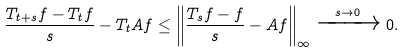Convert formula to latex. <formula><loc_0><loc_0><loc_500><loc_500>\frac { T _ { t + s } f - T _ { t } f } { s } - T _ { t } A f \leq \left \| \frac { T _ { s } f - f } { s } - A f \right \| _ { \infty } \xrightarrow [ ] { s \to 0 } 0 .</formula> 